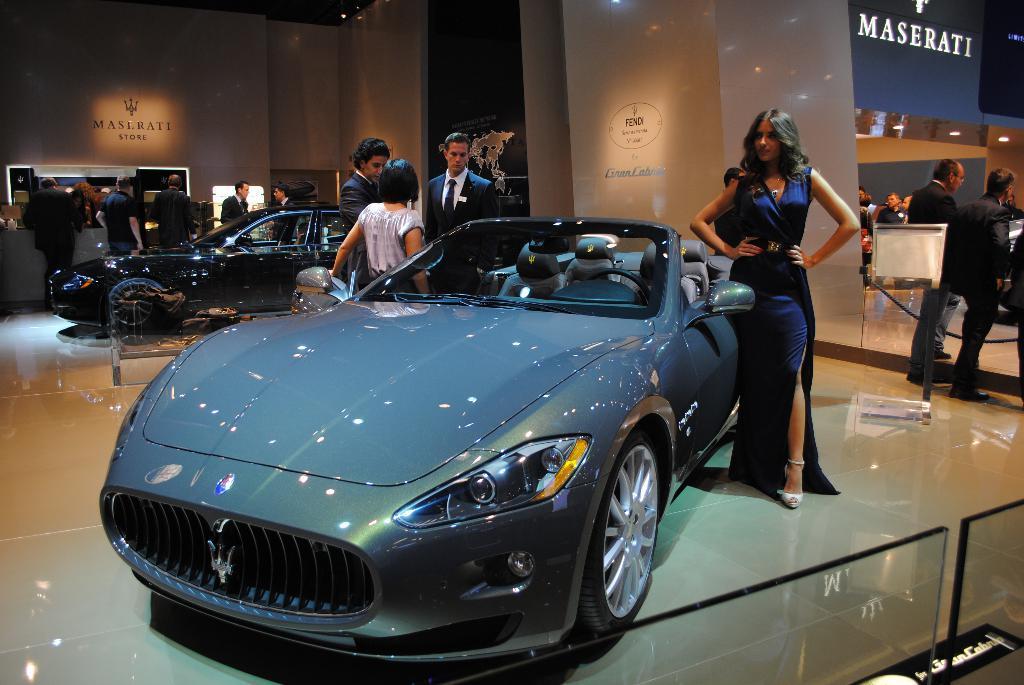Please provide a concise description of this image. This picture shows couple of cars in the showroom and we see a woman standing on the side of a car and we see few people standing, 